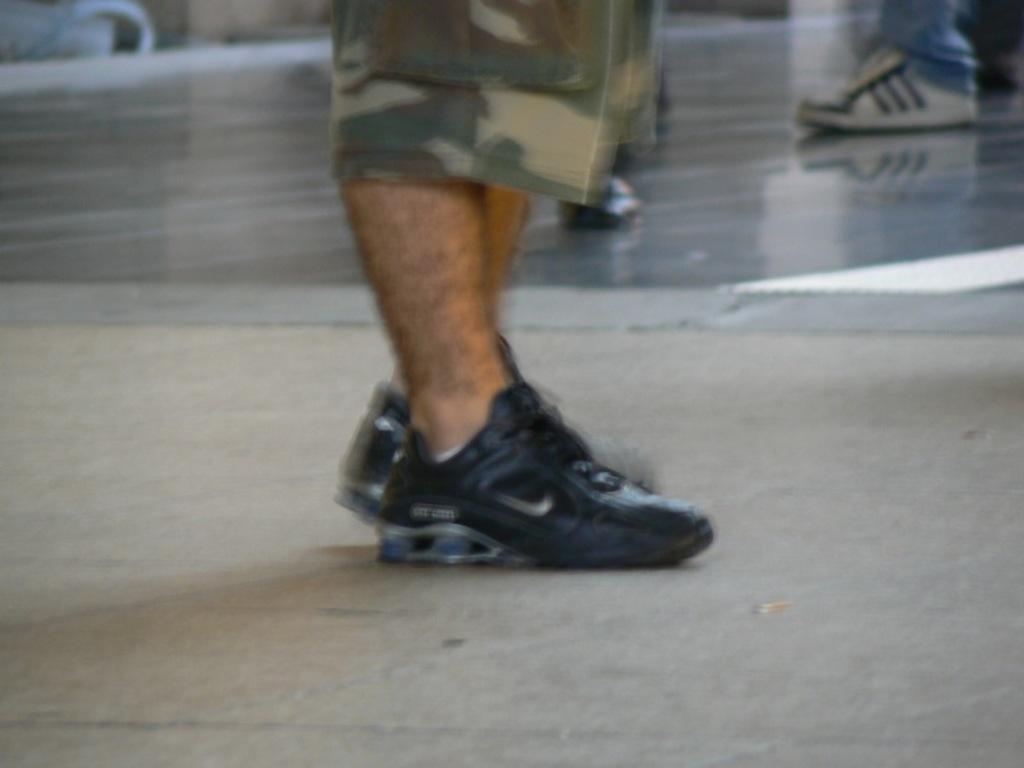Can you describe this image briefly? In this image there is person leg wearing shoeś, the person is standing on the floor. 